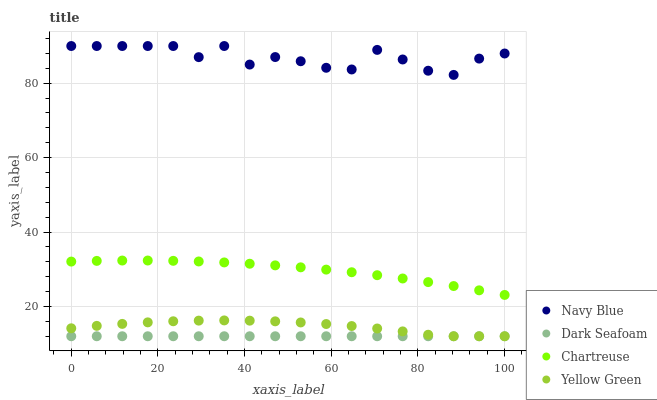Does Dark Seafoam have the minimum area under the curve?
Answer yes or no. Yes. Does Navy Blue have the maximum area under the curve?
Answer yes or no. Yes. Does Chartreuse have the minimum area under the curve?
Answer yes or no. No. Does Chartreuse have the maximum area under the curve?
Answer yes or no. No. Is Dark Seafoam the smoothest?
Answer yes or no. Yes. Is Navy Blue the roughest?
Answer yes or no. Yes. Is Chartreuse the smoothest?
Answer yes or no. No. Is Chartreuse the roughest?
Answer yes or no. No. Does Dark Seafoam have the lowest value?
Answer yes or no. Yes. Does Chartreuse have the lowest value?
Answer yes or no. No. Does Navy Blue have the highest value?
Answer yes or no. Yes. Does Chartreuse have the highest value?
Answer yes or no. No. Is Dark Seafoam less than Chartreuse?
Answer yes or no. Yes. Is Chartreuse greater than Yellow Green?
Answer yes or no. Yes. Does Dark Seafoam intersect Yellow Green?
Answer yes or no. Yes. Is Dark Seafoam less than Yellow Green?
Answer yes or no. No. Is Dark Seafoam greater than Yellow Green?
Answer yes or no. No. Does Dark Seafoam intersect Chartreuse?
Answer yes or no. No. 